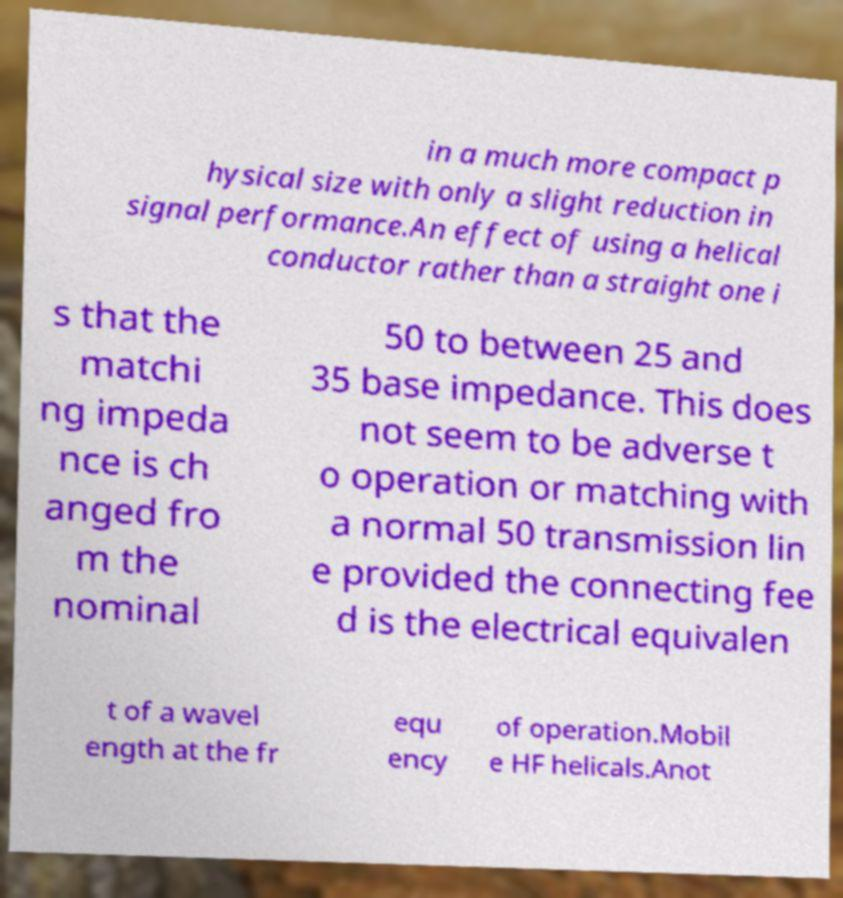Please identify and transcribe the text found in this image. in a much more compact p hysical size with only a slight reduction in signal performance.An effect of using a helical conductor rather than a straight one i s that the matchi ng impeda nce is ch anged fro m the nominal 50 to between 25 and 35 base impedance. This does not seem to be adverse t o operation or matching with a normal 50 transmission lin e provided the connecting fee d is the electrical equivalen t of a wavel ength at the fr equ ency of operation.Mobil e HF helicals.Anot 